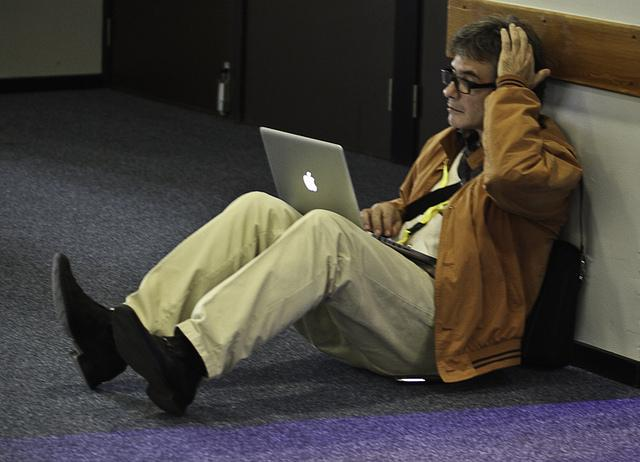Why is this man sitting down?

Choices:
A) to drink
B) to eat
C) to rest
D) to work to work 